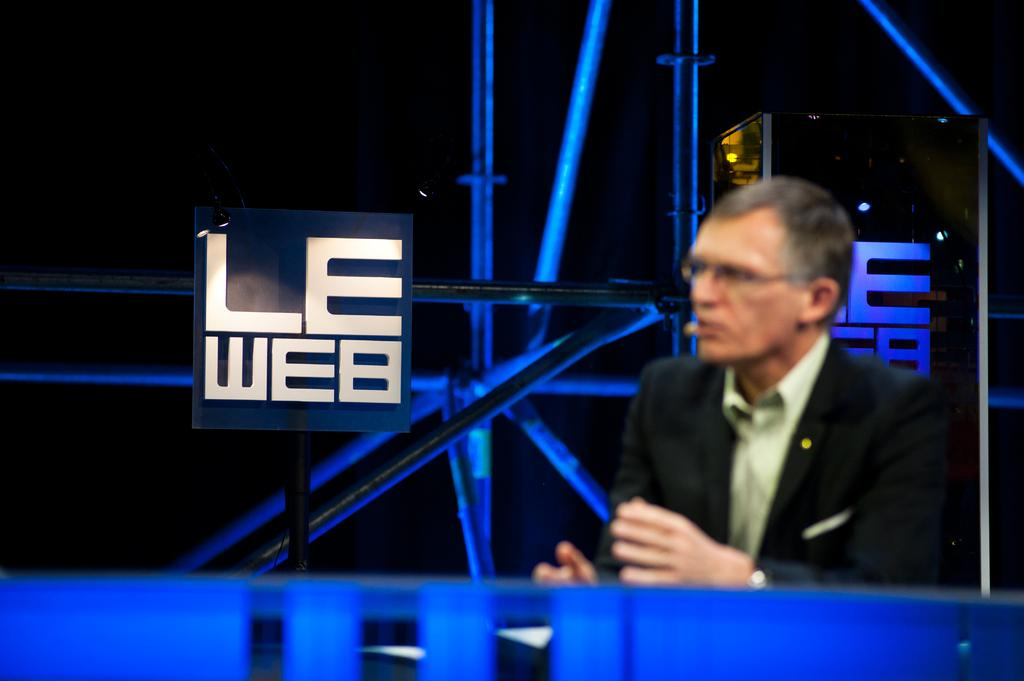<image>
Provide a brief description of the given image. A man sits in front of a sign that says Le Web. 